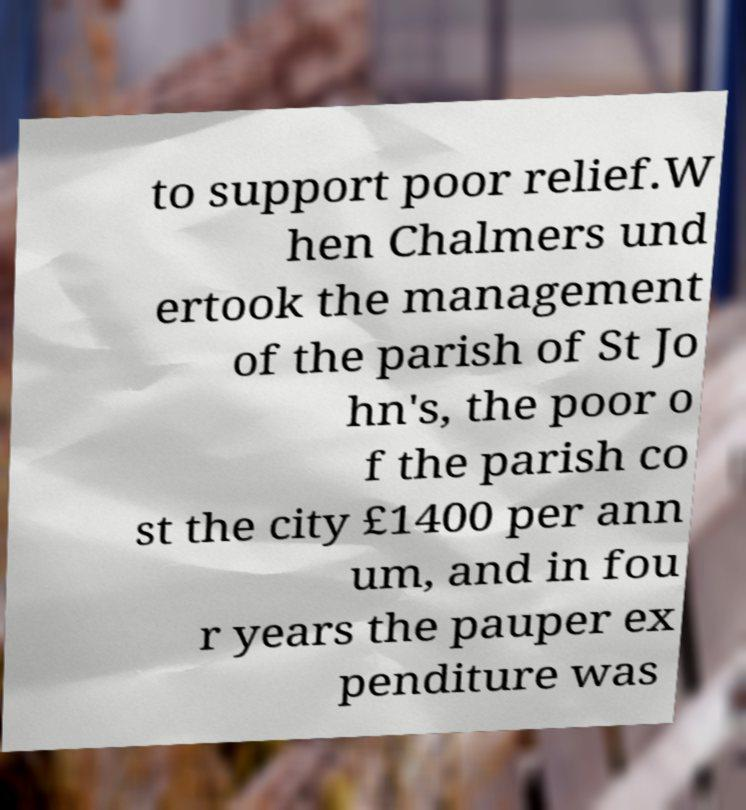What messages or text are displayed in this image? I need them in a readable, typed format. to support poor relief.W hen Chalmers und ertook the management of the parish of St Jo hn's, the poor o f the parish co st the city £1400 per ann um, and in fou r years the pauper ex penditure was 